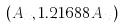<formula> <loc_0><loc_0><loc_500><loc_500>( A _ { x } , 1 . 2 1 6 8 8 A _ { x } )</formula> 